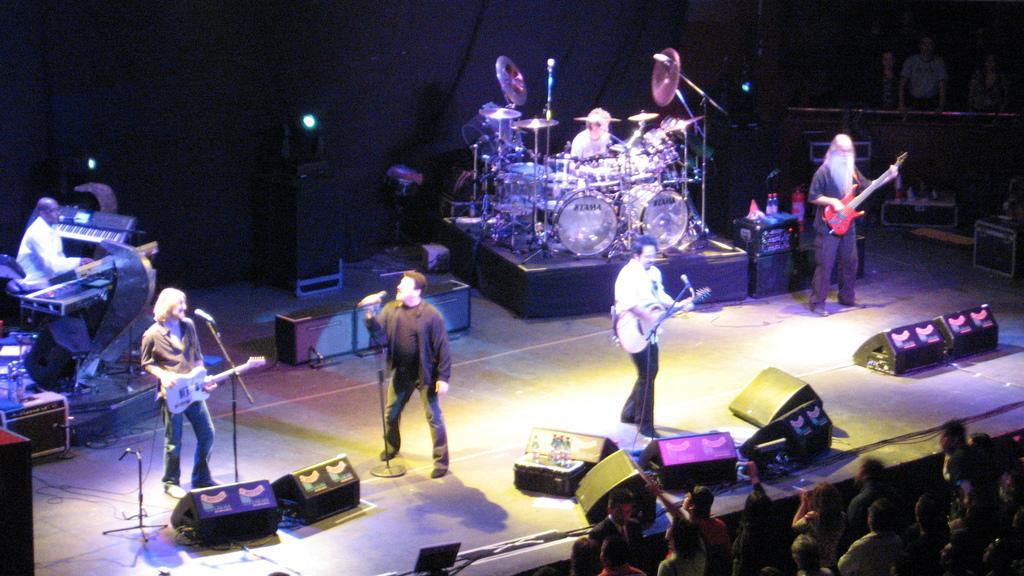Could you give a brief overview of what you see in this image? At the bottom of the image few people are standing. In the middle of the image few people are playing some musical instruments and there are some speakers. At the top of the image there is a wall and few people are standing and watching. 